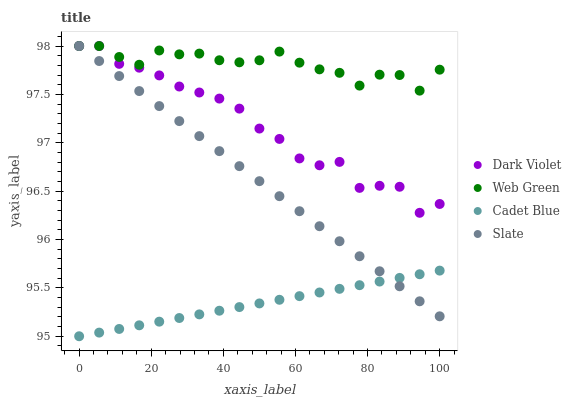Does Cadet Blue have the minimum area under the curve?
Answer yes or no. Yes. Does Web Green have the maximum area under the curve?
Answer yes or no. Yes. Does Web Green have the minimum area under the curve?
Answer yes or no. No. Does Cadet Blue have the maximum area under the curve?
Answer yes or no. No. Is Cadet Blue the smoothest?
Answer yes or no. Yes. Is Dark Violet the roughest?
Answer yes or no. Yes. Is Web Green the smoothest?
Answer yes or no. No. Is Web Green the roughest?
Answer yes or no. No. Does Cadet Blue have the lowest value?
Answer yes or no. Yes. Does Web Green have the lowest value?
Answer yes or no. No. Does Dark Violet have the highest value?
Answer yes or no. Yes. Does Cadet Blue have the highest value?
Answer yes or no. No. Is Cadet Blue less than Web Green?
Answer yes or no. Yes. Is Web Green greater than Cadet Blue?
Answer yes or no. Yes. Does Dark Violet intersect Slate?
Answer yes or no. Yes. Is Dark Violet less than Slate?
Answer yes or no. No. Is Dark Violet greater than Slate?
Answer yes or no. No. Does Cadet Blue intersect Web Green?
Answer yes or no. No. 